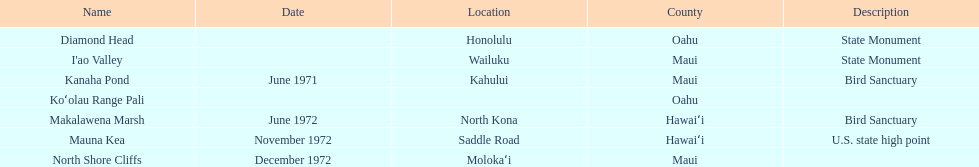Which national natural landmarks in hawaii are in oahu county? Diamond Head, Koʻolau Range Pali. Of these landmarks, which one is listed without a location? Koʻolau Range Pali. Could you parse the entire table? {'header': ['Name', 'Date', 'Location', 'County', 'Description'], 'rows': [['Diamond Head', '', 'Honolulu', 'Oahu', 'State Monument'], ["I'ao Valley", '', 'Wailuku', 'Maui', 'State Monument'], ['Kanaha Pond', 'June 1971', 'Kahului', 'Maui', 'Bird Sanctuary'], ['Koʻolau Range Pali', '', '', 'Oahu', ''], ['Makalawena Marsh', 'June 1972', 'North Kona', 'Hawaiʻi', 'Bird Sanctuary'], ['Mauna Kea', 'November 1972', 'Saddle Road', 'Hawaiʻi', 'U.S. state high point'], ['North Shore Cliffs', 'December 1972', 'Molokaʻi', 'Maui', '']]} 